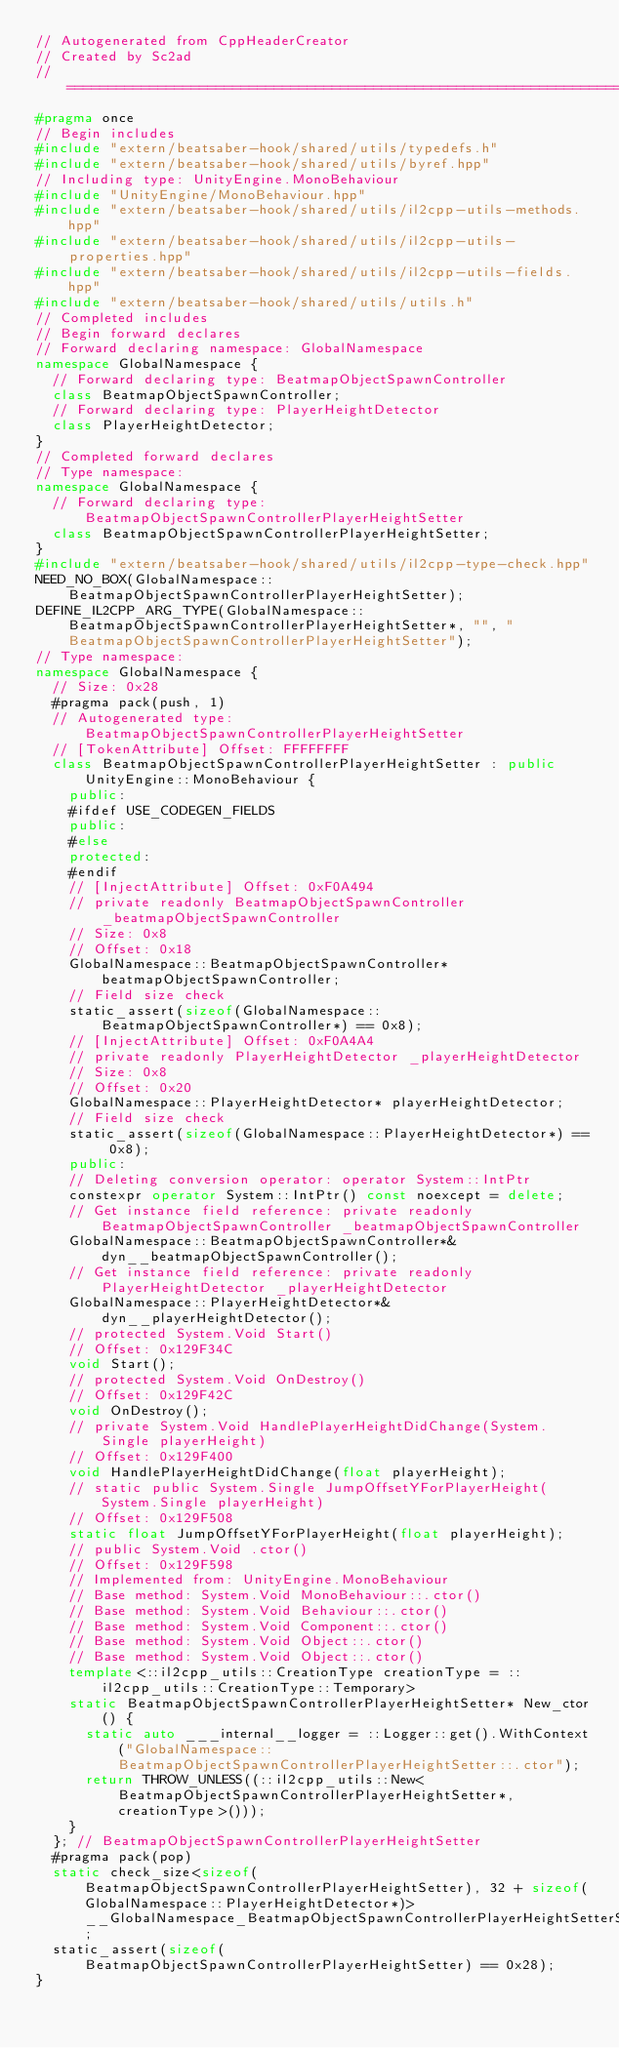Convert code to text. <code><loc_0><loc_0><loc_500><loc_500><_C++_>// Autogenerated from CppHeaderCreator
// Created by Sc2ad
// =========================================================================
#pragma once
// Begin includes
#include "extern/beatsaber-hook/shared/utils/typedefs.h"
#include "extern/beatsaber-hook/shared/utils/byref.hpp"
// Including type: UnityEngine.MonoBehaviour
#include "UnityEngine/MonoBehaviour.hpp"
#include "extern/beatsaber-hook/shared/utils/il2cpp-utils-methods.hpp"
#include "extern/beatsaber-hook/shared/utils/il2cpp-utils-properties.hpp"
#include "extern/beatsaber-hook/shared/utils/il2cpp-utils-fields.hpp"
#include "extern/beatsaber-hook/shared/utils/utils.h"
// Completed includes
// Begin forward declares
// Forward declaring namespace: GlobalNamespace
namespace GlobalNamespace {
  // Forward declaring type: BeatmapObjectSpawnController
  class BeatmapObjectSpawnController;
  // Forward declaring type: PlayerHeightDetector
  class PlayerHeightDetector;
}
// Completed forward declares
// Type namespace: 
namespace GlobalNamespace {
  // Forward declaring type: BeatmapObjectSpawnControllerPlayerHeightSetter
  class BeatmapObjectSpawnControllerPlayerHeightSetter;
}
#include "extern/beatsaber-hook/shared/utils/il2cpp-type-check.hpp"
NEED_NO_BOX(GlobalNamespace::BeatmapObjectSpawnControllerPlayerHeightSetter);
DEFINE_IL2CPP_ARG_TYPE(GlobalNamespace::BeatmapObjectSpawnControllerPlayerHeightSetter*, "", "BeatmapObjectSpawnControllerPlayerHeightSetter");
// Type namespace: 
namespace GlobalNamespace {
  // Size: 0x28
  #pragma pack(push, 1)
  // Autogenerated type: BeatmapObjectSpawnControllerPlayerHeightSetter
  // [TokenAttribute] Offset: FFFFFFFF
  class BeatmapObjectSpawnControllerPlayerHeightSetter : public UnityEngine::MonoBehaviour {
    public:
    #ifdef USE_CODEGEN_FIELDS
    public:
    #else
    protected:
    #endif
    // [InjectAttribute] Offset: 0xF0A494
    // private readonly BeatmapObjectSpawnController _beatmapObjectSpawnController
    // Size: 0x8
    // Offset: 0x18
    GlobalNamespace::BeatmapObjectSpawnController* beatmapObjectSpawnController;
    // Field size check
    static_assert(sizeof(GlobalNamespace::BeatmapObjectSpawnController*) == 0x8);
    // [InjectAttribute] Offset: 0xF0A4A4
    // private readonly PlayerHeightDetector _playerHeightDetector
    // Size: 0x8
    // Offset: 0x20
    GlobalNamespace::PlayerHeightDetector* playerHeightDetector;
    // Field size check
    static_assert(sizeof(GlobalNamespace::PlayerHeightDetector*) == 0x8);
    public:
    // Deleting conversion operator: operator System::IntPtr
    constexpr operator System::IntPtr() const noexcept = delete;
    // Get instance field reference: private readonly BeatmapObjectSpawnController _beatmapObjectSpawnController
    GlobalNamespace::BeatmapObjectSpawnController*& dyn__beatmapObjectSpawnController();
    // Get instance field reference: private readonly PlayerHeightDetector _playerHeightDetector
    GlobalNamespace::PlayerHeightDetector*& dyn__playerHeightDetector();
    // protected System.Void Start()
    // Offset: 0x129F34C
    void Start();
    // protected System.Void OnDestroy()
    // Offset: 0x129F42C
    void OnDestroy();
    // private System.Void HandlePlayerHeightDidChange(System.Single playerHeight)
    // Offset: 0x129F400
    void HandlePlayerHeightDidChange(float playerHeight);
    // static public System.Single JumpOffsetYForPlayerHeight(System.Single playerHeight)
    // Offset: 0x129F508
    static float JumpOffsetYForPlayerHeight(float playerHeight);
    // public System.Void .ctor()
    // Offset: 0x129F598
    // Implemented from: UnityEngine.MonoBehaviour
    // Base method: System.Void MonoBehaviour::.ctor()
    // Base method: System.Void Behaviour::.ctor()
    // Base method: System.Void Component::.ctor()
    // Base method: System.Void Object::.ctor()
    // Base method: System.Void Object::.ctor()
    template<::il2cpp_utils::CreationType creationType = ::il2cpp_utils::CreationType::Temporary>
    static BeatmapObjectSpawnControllerPlayerHeightSetter* New_ctor() {
      static auto ___internal__logger = ::Logger::get().WithContext("GlobalNamespace::BeatmapObjectSpawnControllerPlayerHeightSetter::.ctor");
      return THROW_UNLESS((::il2cpp_utils::New<BeatmapObjectSpawnControllerPlayerHeightSetter*, creationType>()));
    }
  }; // BeatmapObjectSpawnControllerPlayerHeightSetter
  #pragma pack(pop)
  static check_size<sizeof(BeatmapObjectSpawnControllerPlayerHeightSetter), 32 + sizeof(GlobalNamespace::PlayerHeightDetector*)> __GlobalNamespace_BeatmapObjectSpawnControllerPlayerHeightSetterSizeCheck;
  static_assert(sizeof(BeatmapObjectSpawnControllerPlayerHeightSetter) == 0x28);
}</code> 